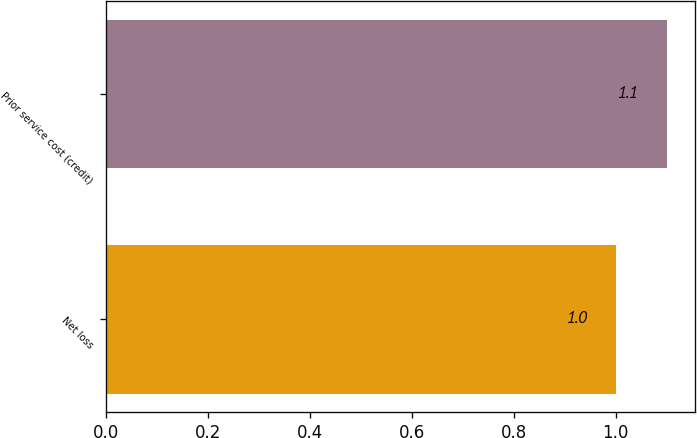<chart> <loc_0><loc_0><loc_500><loc_500><bar_chart><fcel>Net loss<fcel>Prior service cost (credit)<nl><fcel>1<fcel>1.1<nl></chart> 